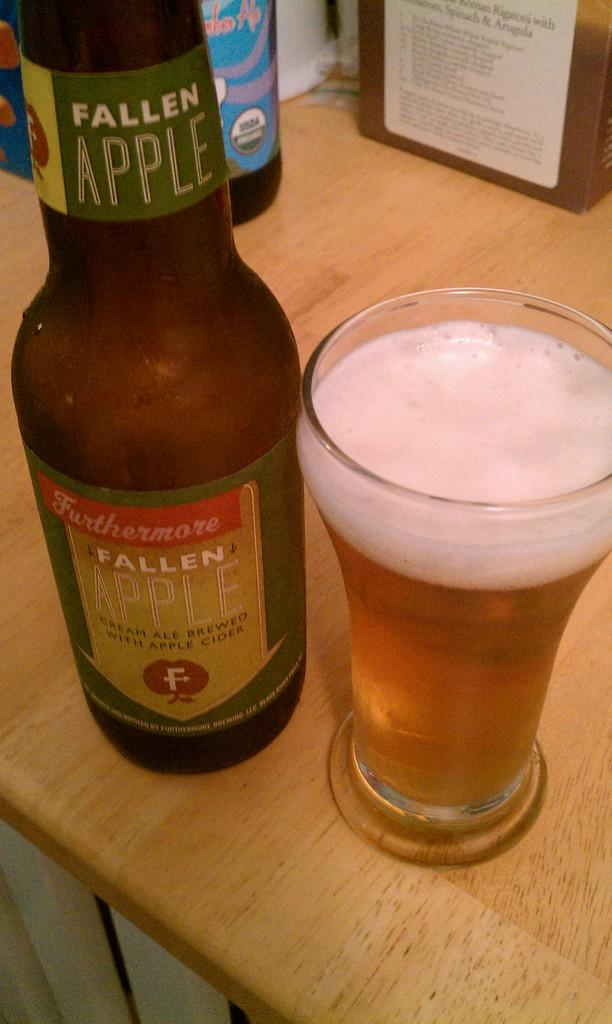<image>
Render a clear and concise summary of the photo. Fallen Apple cream ale has been poured into the glass on the right. 